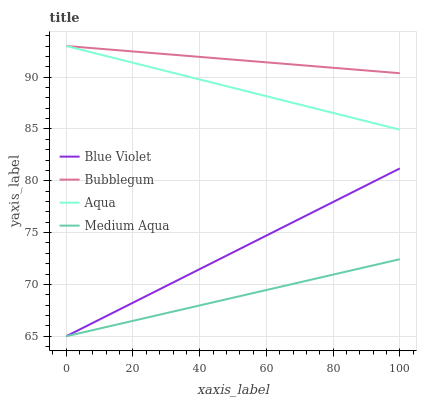Does Medium Aqua have the minimum area under the curve?
Answer yes or no. Yes. Does Bubblegum have the maximum area under the curve?
Answer yes or no. Yes. Does Aqua have the minimum area under the curve?
Answer yes or no. No. Does Aqua have the maximum area under the curve?
Answer yes or no. No. Is Bubblegum the smoothest?
Answer yes or no. Yes. Is Aqua the roughest?
Answer yes or no. Yes. Is Aqua the smoothest?
Answer yes or no. No. Is Bubblegum the roughest?
Answer yes or no. No. Does Medium Aqua have the lowest value?
Answer yes or no. Yes. Does Aqua have the lowest value?
Answer yes or no. No. Does Bubblegum have the highest value?
Answer yes or no. Yes. Does Blue Violet have the highest value?
Answer yes or no. No. Is Medium Aqua less than Aqua?
Answer yes or no. Yes. Is Bubblegum greater than Blue Violet?
Answer yes or no. Yes. Does Blue Violet intersect Medium Aqua?
Answer yes or no. Yes. Is Blue Violet less than Medium Aqua?
Answer yes or no. No. Is Blue Violet greater than Medium Aqua?
Answer yes or no. No. Does Medium Aqua intersect Aqua?
Answer yes or no. No. 